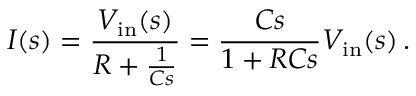<formula> <loc_0><loc_0><loc_500><loc_500>I ( s ) = { \frac { V _ { i n } ( s ) } { R + { \frac { 1 } { C s } } } } = { \frac { C s } { 1 + R C s } } V _ { i n } ( s ) \, .</formula> 